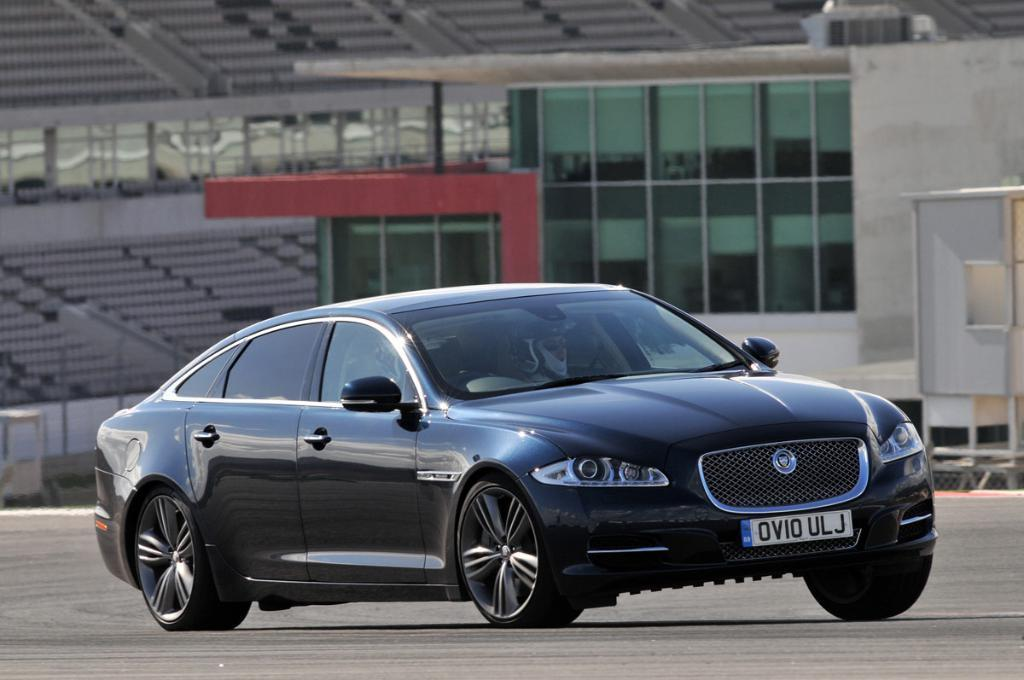How many people are in the car in the image? There are two persons in the car. Where is the car located in the image? The car is on the road. What can be seen in the background of the image? There is a building, chairs, poles, glasses, and other objects in the background. Can you see any fish swimming in the car in the image? No, there are no fish present in the image. 